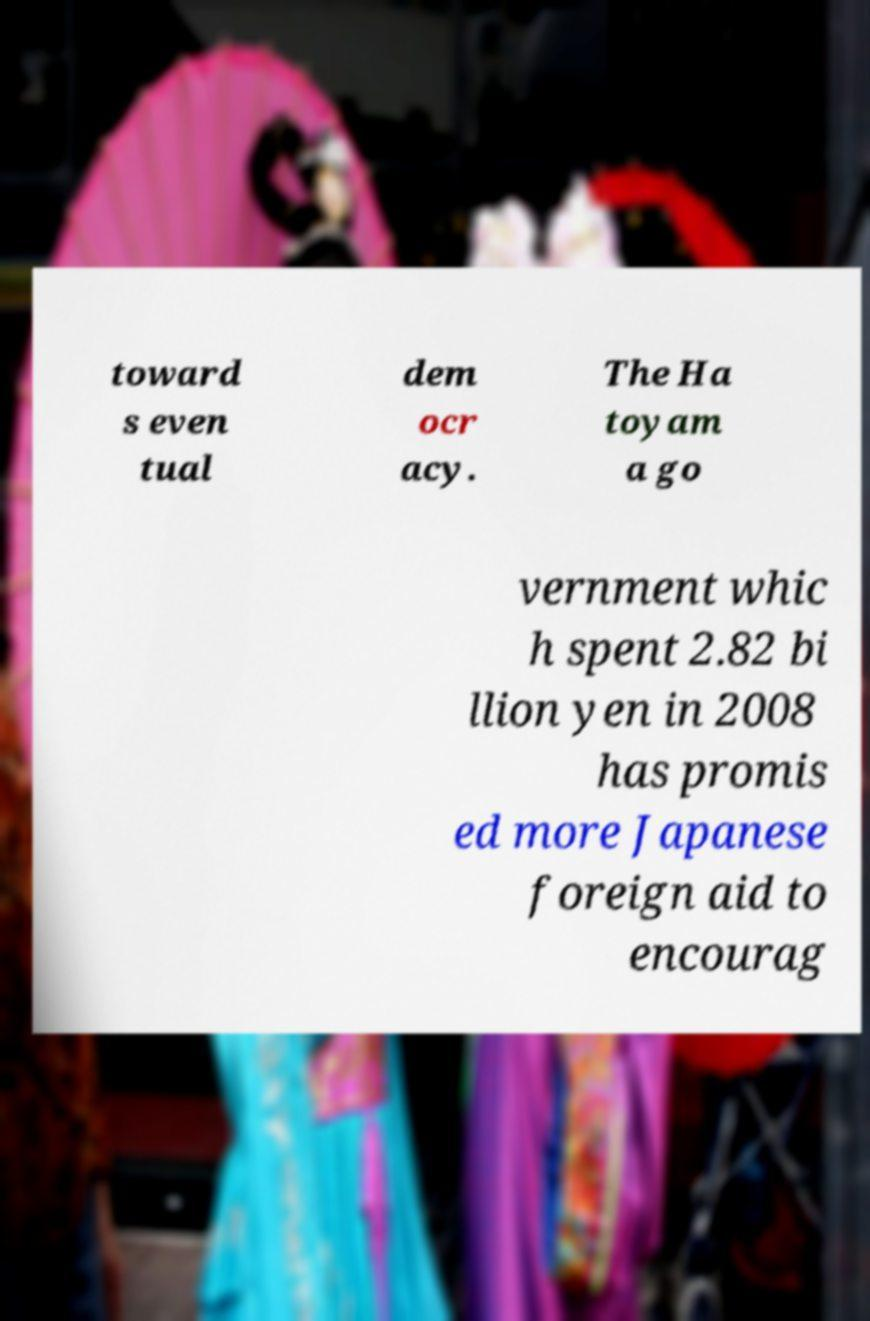Can you read and provide the text displayed in the image?This photo seems to have some interesting text. Can you extract and type it out for me? toward s even tual dem ocr acy. The Ha toyam a go vernment whic h spent 2.82 bi llion yen in 2008 has promis ed more Japanese foreign aid to encourag 